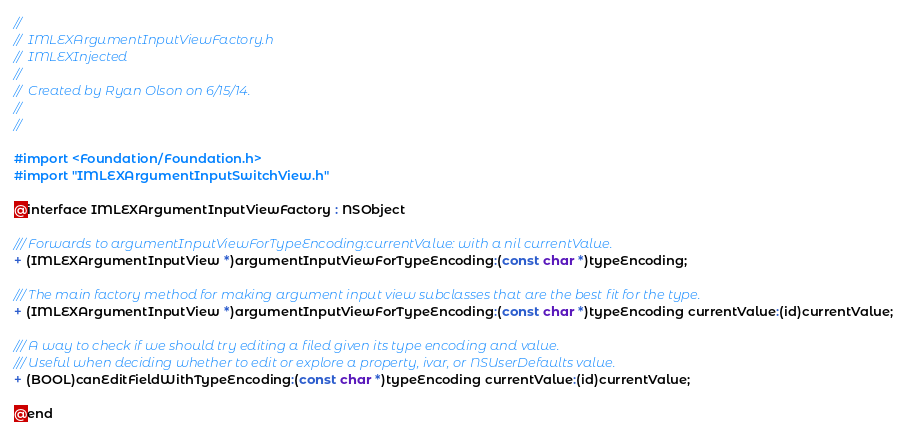<code> <loc_0><loc_0><loc_500><loc_500><_C_>//
//  IMLEXArgumentInputViewFactory.h
//  IMLEXInjected
//
//  Created by Ryan Olson on 6/15/14.
//
//

#import <Foundation/Foundation.h>
#import "IMLEXArgumentInputSwitchView.h"

@interface IMLEXArgumentInputViewFactory : NSObject

/// Forwards to argumentInputViewForTypeEncoding:currentValue: with a nil currentValue.
+ (IMLEXArgumentInputView *)argumentInputViewForTypeEncoding:(const char *)typeEncoding;

/// The main factory method for making argument input view subclasses that are the best fit for the type.
+ (IMLEXArgumentInputView *)argumentInputViewForTypeEncoding:(const char *)typeEncoding currentValue:(id)currentValue;

/// A way to check if we should try editing a filed given its type encoding and value.
/// Useful when deciding whether to edit or explore a property, ivar, or NSUserDefaults value.
+ (BOOL)canEditFieldWithTypeEncoding:(const char *)typeEncoding currentValue:(id)currentValue;

@end
</code> 